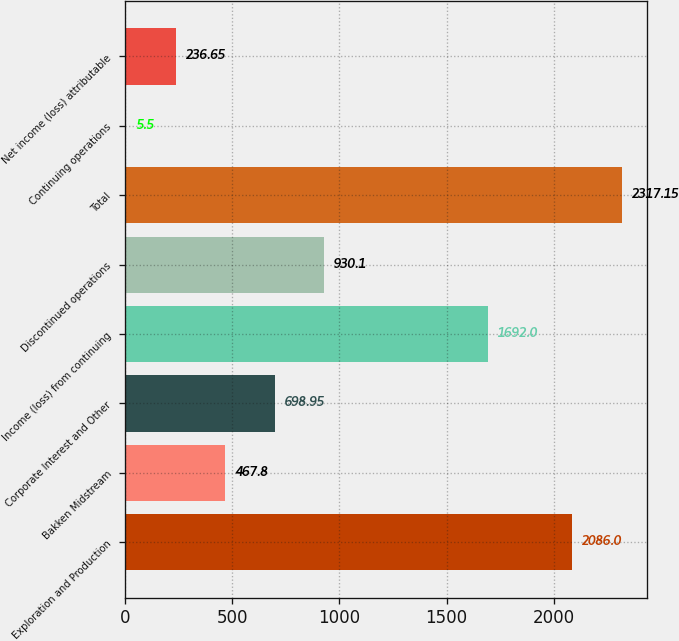Convert chart to OTSL. <chart><loc_0><loc_0><loc_500><loc_500><bar_chart><fcel>Exploration and Production<fcel>Bakken Midstream<fcel>Corporate Interest and Other<fcel>Income (loss) from continuing<fcel>Discontinued operations<fcel>Total<fcel>Continuing operations<fcel>Net income (loss) attributable<nl><fcel>2086<fcel>467.8<fcel>698.95<fcel>1692<fcel>930.1<fcel>2317.15<fcel>5.5<fcel>236.65<nl></chart> 